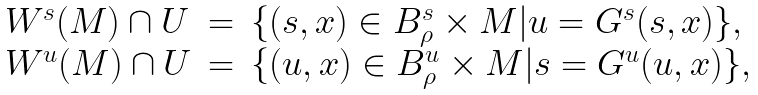<formula> <loc_0><loc_0><loc_500><loc_500>\left . \begin{array} { l l l } W ^ { s } ( M ) \cap U & = & \{ ( s , x ) \in B _ { \rho } ^ { s } \times M | u = G ^ { s } ( s , x ) \} , \\ W ^ { u } ( M ) \cap U & = & \{ ( u , x ) \in B _ { \rho } ^ { u } \times M | s = G ^ { u } ( u , x ) \} , \end{array} \right .</formula> 